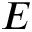<formula> <loc_0><loc_0><loc_500><loc_500>E</formula> 